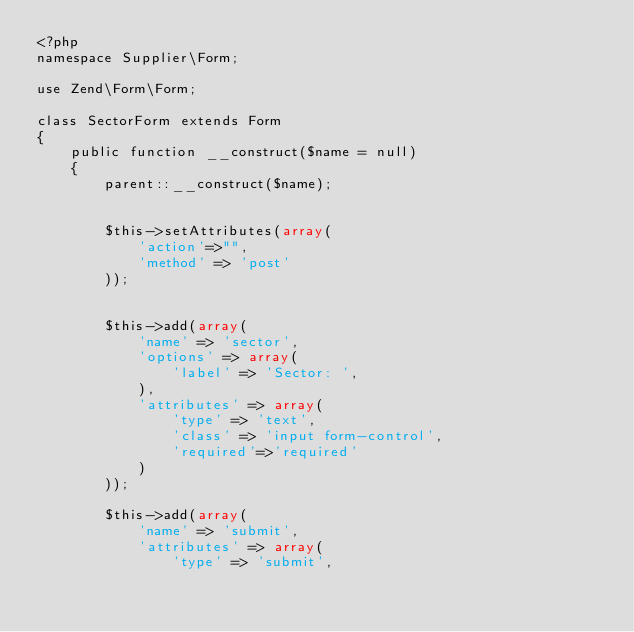Convert code to text. <code><loc_0><loc_0><loc_500><loc_500><_PHP_><?php
namespace Supplier\Form;

use Zend\Form\Form;

class SectorForm extends Form
{
    public function __construct($name = null)
    {
        parent::__construct($name);
        
        
        $this->setAttributes(array(
            'action'=>"",
            'method' => 'post'
        ));
        
        
        $this->add(array(
            'name' => 'sector',
            'options' => array(
                'label' => 'Sector: ',
            ),
            'attributes' => array(
                'type' => 'text',
                'class' => 'input form-control',
                'required'=>'required'
            )
        ));
        
        $this->add(array(
            'name' => 'submit',
            'attributes' => array(
                'type' => 'submit',</code> 